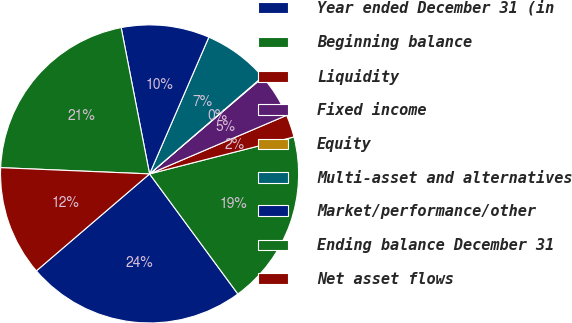Convert chart. <chart><loc_0><loc_0><loc_500><loc_500><pie_chart><fcel>Year ended December 31 (in<fcel>Beginning balance<fcel>Liquidity<fcel>Fixed income<fcel>Equity<fcel>Multi-asset and alternatives<fcel>Market/performance/other<fcel>Ending balance December 31<fcel>Net asset flows<nl><fcel>23.82%<fcel>18.9%<fcel>2.44%<fcel>4.81%<fcel>0.06%<fcel>7.19%<fcel>9.56%<fcel>21.28%<fcel>11.94%<nl></chart> 